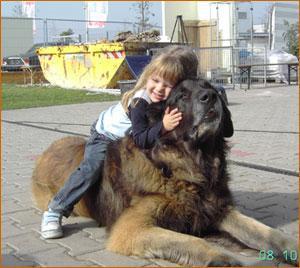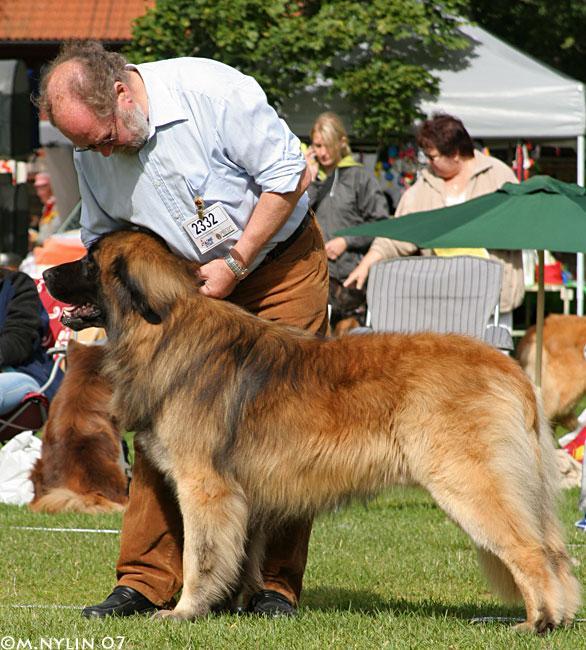The first image is the image on the left, the second image is the image on the right. Examine the images to the left and right. Is the description "One of the dogs is alone in one of the pictures." accurate? Answer yes or no. No. 